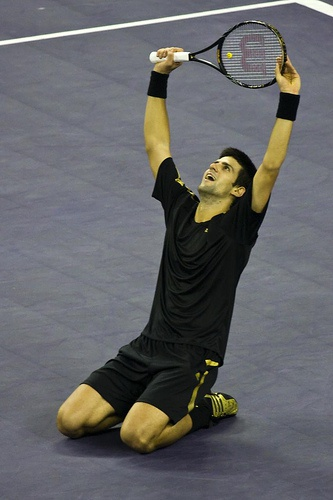Describe the objects in this image and their specific colors. I can see people in gray, black, and tan tones and tennis racket in gray, darkgray, black, and ivory tones in this image. 